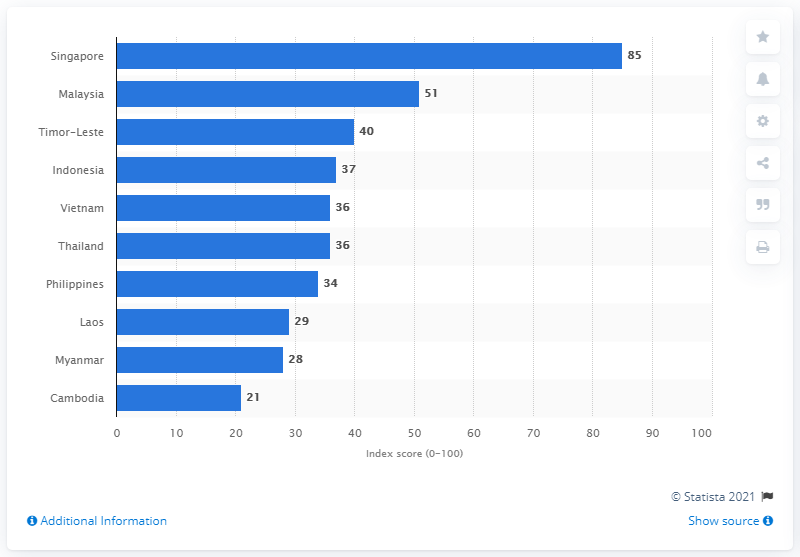Give some essential details in this illustration. According to the corruption perception index in 2020, Cambodia's score was 21, indicating a moderate level of corruption in the country. According to the Corruption Perceptions Index 2020, Singapore's score was 85. Singapore was the least corrupt country in the ASEAN region in 2020, according to the Corruption Perceptions Index published by Transparency International. 